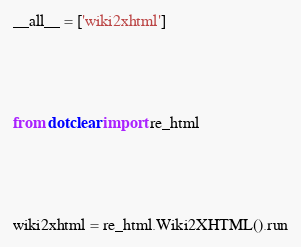<code> <loc_0><loc_0><loc_500><loc_500><_Python_>__all__ = ['wiki2xhtml']





from dotclear import re_html





wiki2xhtml = re_html.Wiki2XHTML().run
</code> 